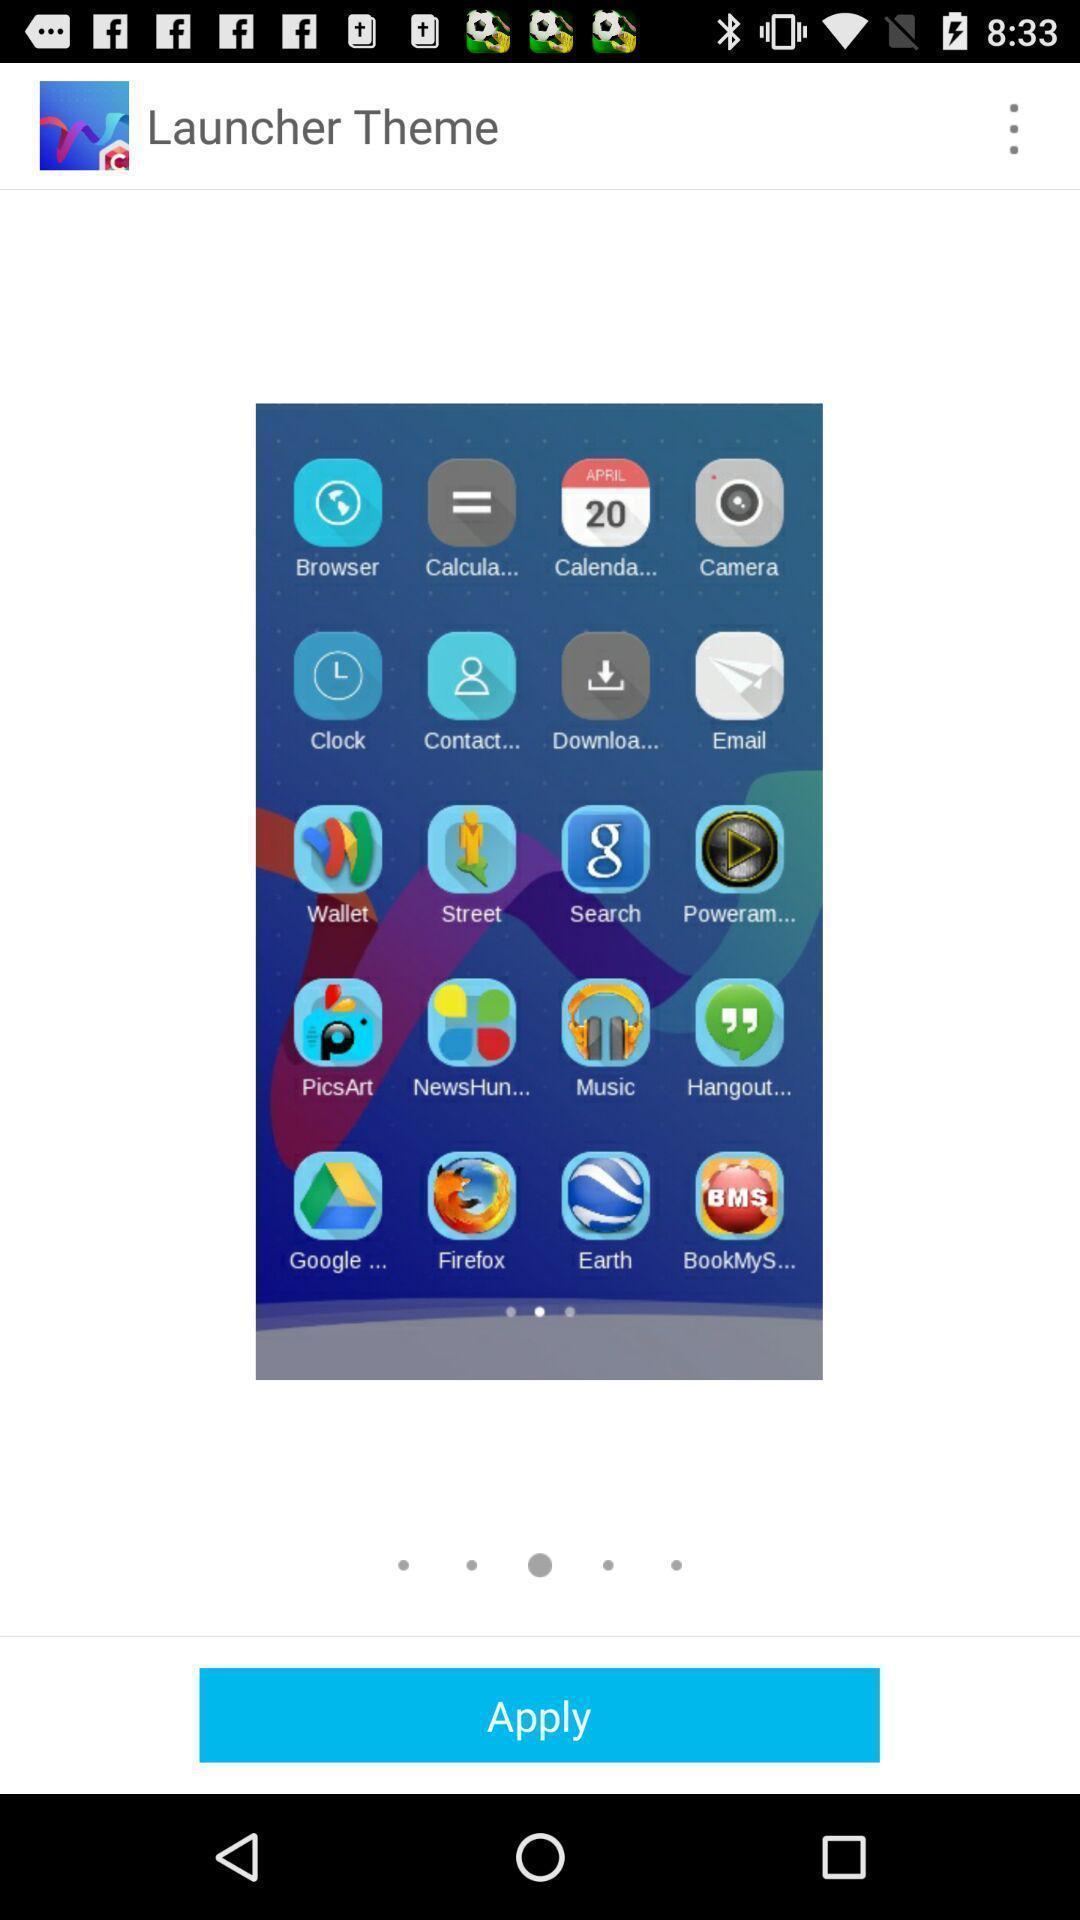Summarize the information in this screenshot. Page shows the launcher theme option to apply. 